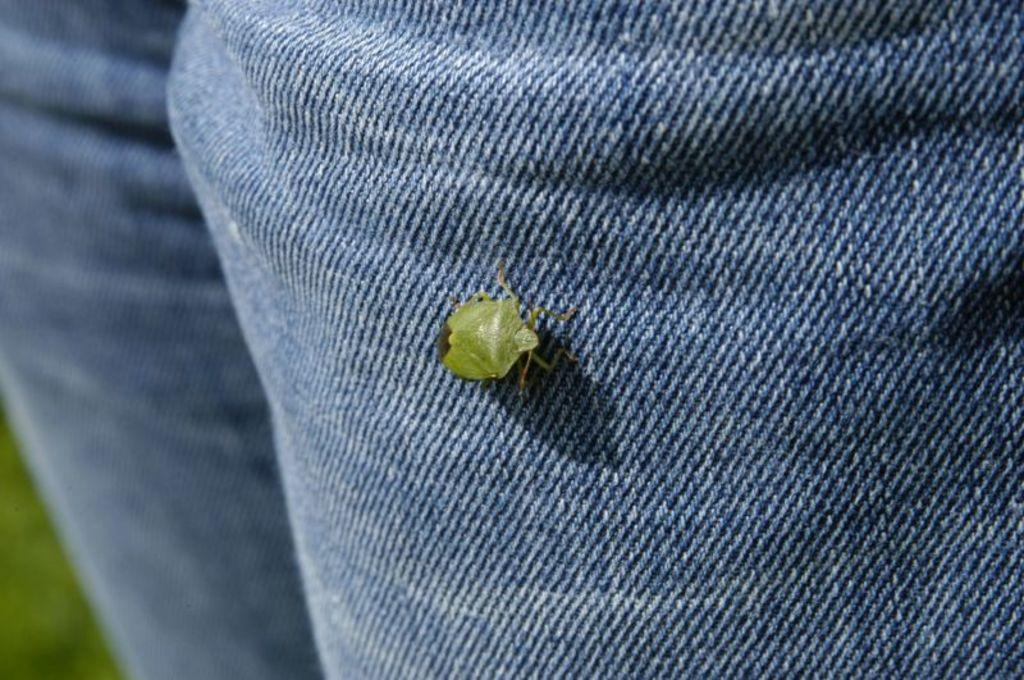What is present on the cloth in the image? There is a bug on a cloth in the image. Can you describe any other notable features in the image? There is a blurred area in the bottom left corner of the image. What is the title of the book that the bug is reading in the image? There is no book or reading activity present in the image; it features a bug on a cloth. 